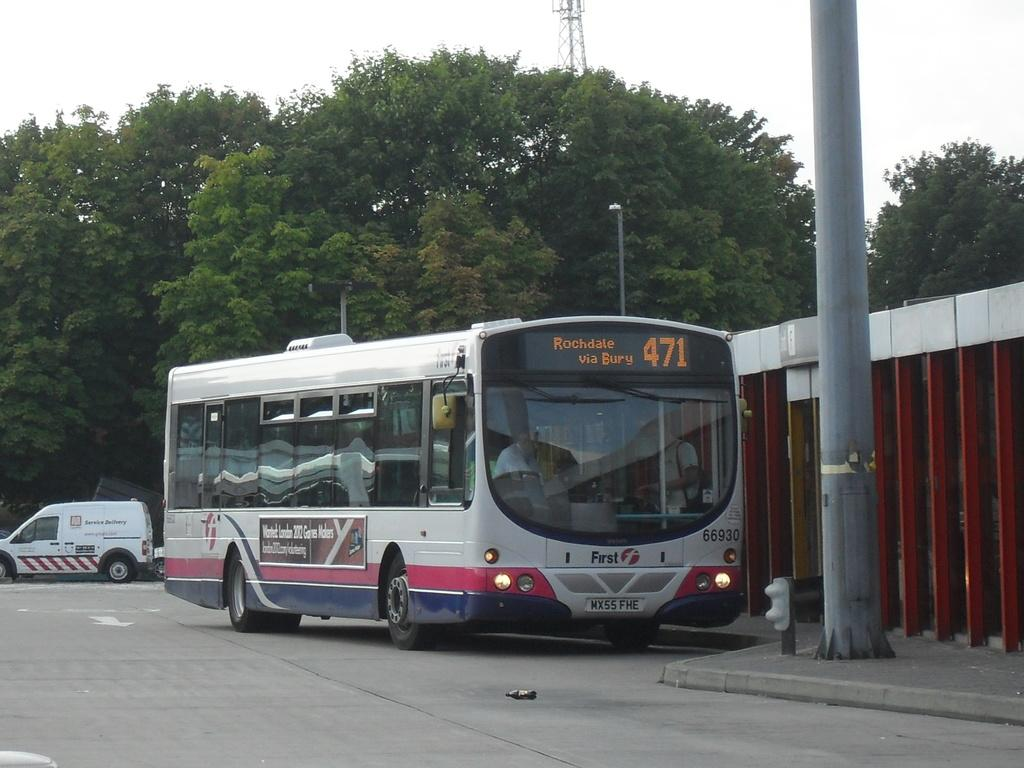What type of vehicles can be seen on the road in the image? There are vehicles on the road, including a bus. Can you describe the bus in the image? The bus is among the vehicles, and there is a pole in front of it. What can be seen in the background of the image? Trees are visible in the background. Who might be inside the bus? People are inside the bus. How many fish can be seen swimming in the middle of the road in the image? There are no fish visible in the image, and the road is not a body of water where fish would swim. 